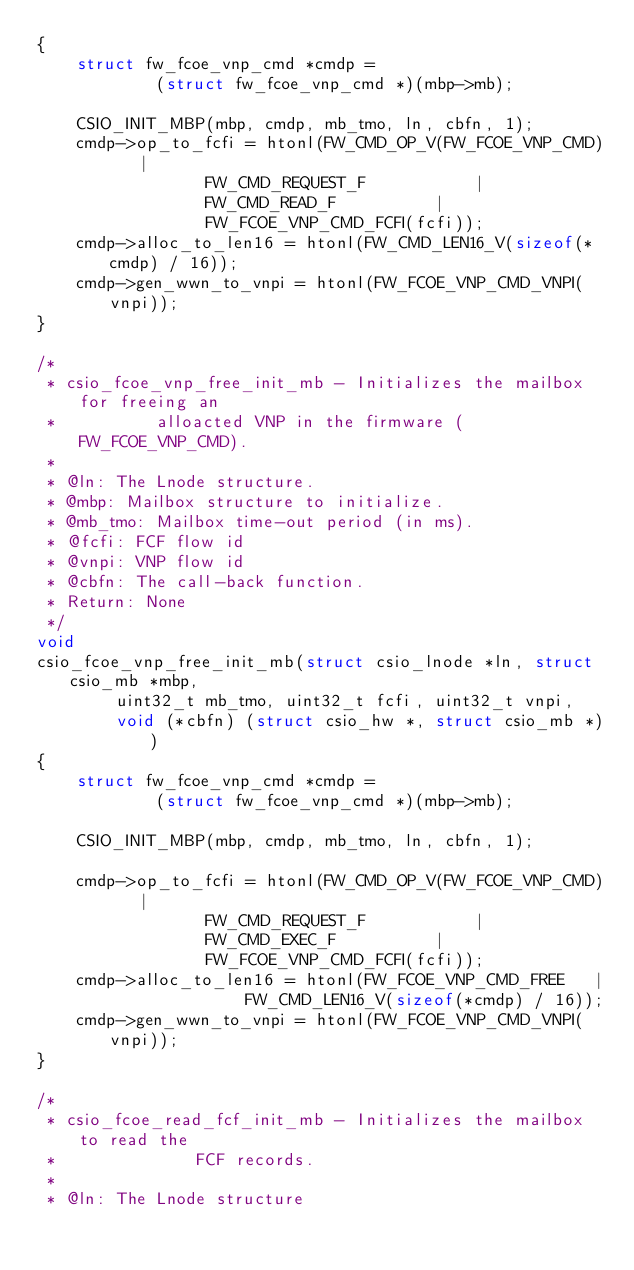Convert code to text. <code><loc_0><loc_0><loc_500><loc_500><_C_>{
	struct fw_fcoe_vnp_cmd *cmdp =
			(struct fw_fcoe_vnp_cmd *)(mbp->mb);

	CSIO_INIT_MBP(mbp, cmdp, mb_tmo, ln, cbfn, 1);
	cmdp->op_to_fcfi = htonl(FW_CMD_OP_V(FW_FCOE_VNP_CMD)	|
				 FW_CMD_REQUEST_F			|
				 FW_CMD_READ_F			|
				 FW_FCOE_VNP_CMD_FCFI(fcfi));
	cmdp->alloc_to_len16 = htonl(FW_CMD_LEN16_V(sizeof(*cmdp) / 16));
	cmdp->gen_wwn_to_vnpi = htonl(FW_FCOE_VNP_CMD_VNPI(vnpi));
}

/*
 * csio_fcoe_vnp_free_init_mb - Initializes the mailbox for freeing an
 *			alloacted VNP in the firmware (FW_FCOE_VNP_CMD).
 *
 * @ln: The Lnode structure.
 * @mbp: Mailbox structure to initialize.
 * @mb_tmo: Mailbox time-out period (in ms).
 * @fcfi: FCF flow id
 * @vnpi: VNP flow id
 * @cbfn: The call-back function.
 * Return: None
 */
void
csio_fcoe_vnp_free_init_mb(struct csio_lnode *ln, struct csio_mb *mbp,
		uint32_t mb_tmo, uint32_t fcfi, uint32_t vnpi,
		void (*cbfn) (struct csio_hw *, struct csio_mb *))
{
	struct fw_fcoe_vnp_cmd *cmdp =
			(struct fw_fcoe_vnp_cmd *)(mbp->mb);

	CSIO_INIT_MBP(mbp, cmdp, mb_tmo, ln, cbfn, 1);

	cmdp->op_to_fcfi = htonl(FW_CMD_OP_V(FW_FCOE_VNP_CMD)	|
				 FW_CMD_REQUEST_F			|
				 FW_CMD_EXEC_F			|
				 FW_FCOE_VNP_CMD_FCFI(fcfi));
	cmdp->alloc_to_len16 = htonl(FW_FCOE_VNP_CMD_FREE	|
				     FW_CMD_LEN16_V(sizeof(*cmdp) / 16));
	cmdp->gen_wwn_to_vnpi = htonl(FW_FCOE_VNP_CMD_VNPI(vnpi));
}

/*
 * csio_fcoe_read_fcf_init_mb - Initializes the mailbox to read the
 *				FCF records.
 *
 * @ln: The Lnode structure</code> 